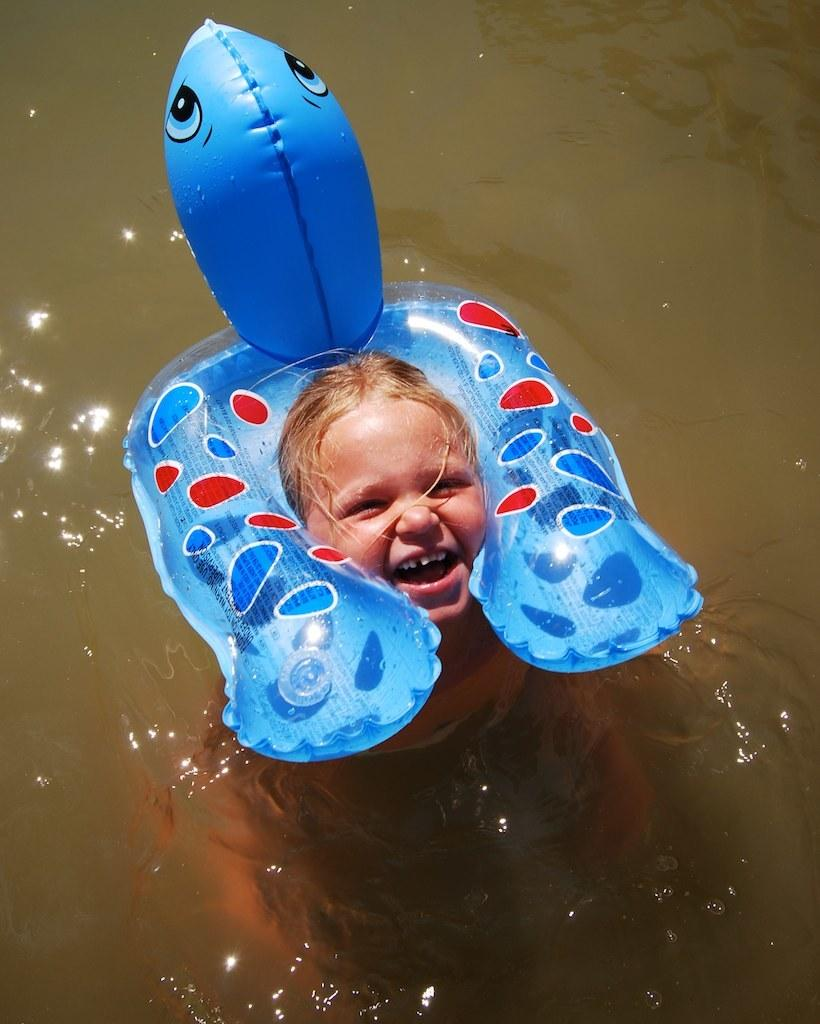Who is in the water in the image? There is a girl in the water in the image. What is the girl wearing to stay afloat? The girl is wearing an inflatable. What type of mint is growing near the girl in the image? There is no mint visible in the image; the girl is in the water and wearing an inflatable. 